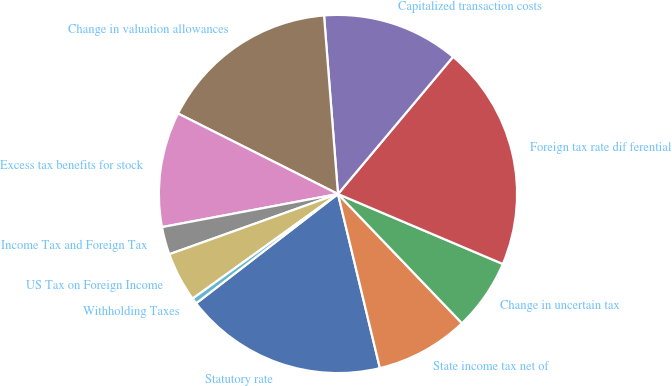Convert chart. <chart><loc_0><loc_0><loc_500><loc_500><pie_chart><fcel>Statutory rate<fcel>State income tax net of<fcel>Change in uncertain tax<fcel>Foreign tax rate dif ferential<fcel>Capitalized transaction costs<fcel>Change in valuation allowances<fcel>Excess tax benefits for stock<fcel>Income Tax and Foreign Tax<fcel>US Tax on Foreign Income<fcel>Withholding Taxes<nl><fcel>18.31%<fcel>8.41%<fcel>6.44%<fcel>20.28%<fcel>12.35%<fcel>16.34%<fcel>10.38%<fcel>2.5%<fcel>4.47%<fcel>0.52%<nl></chart> 